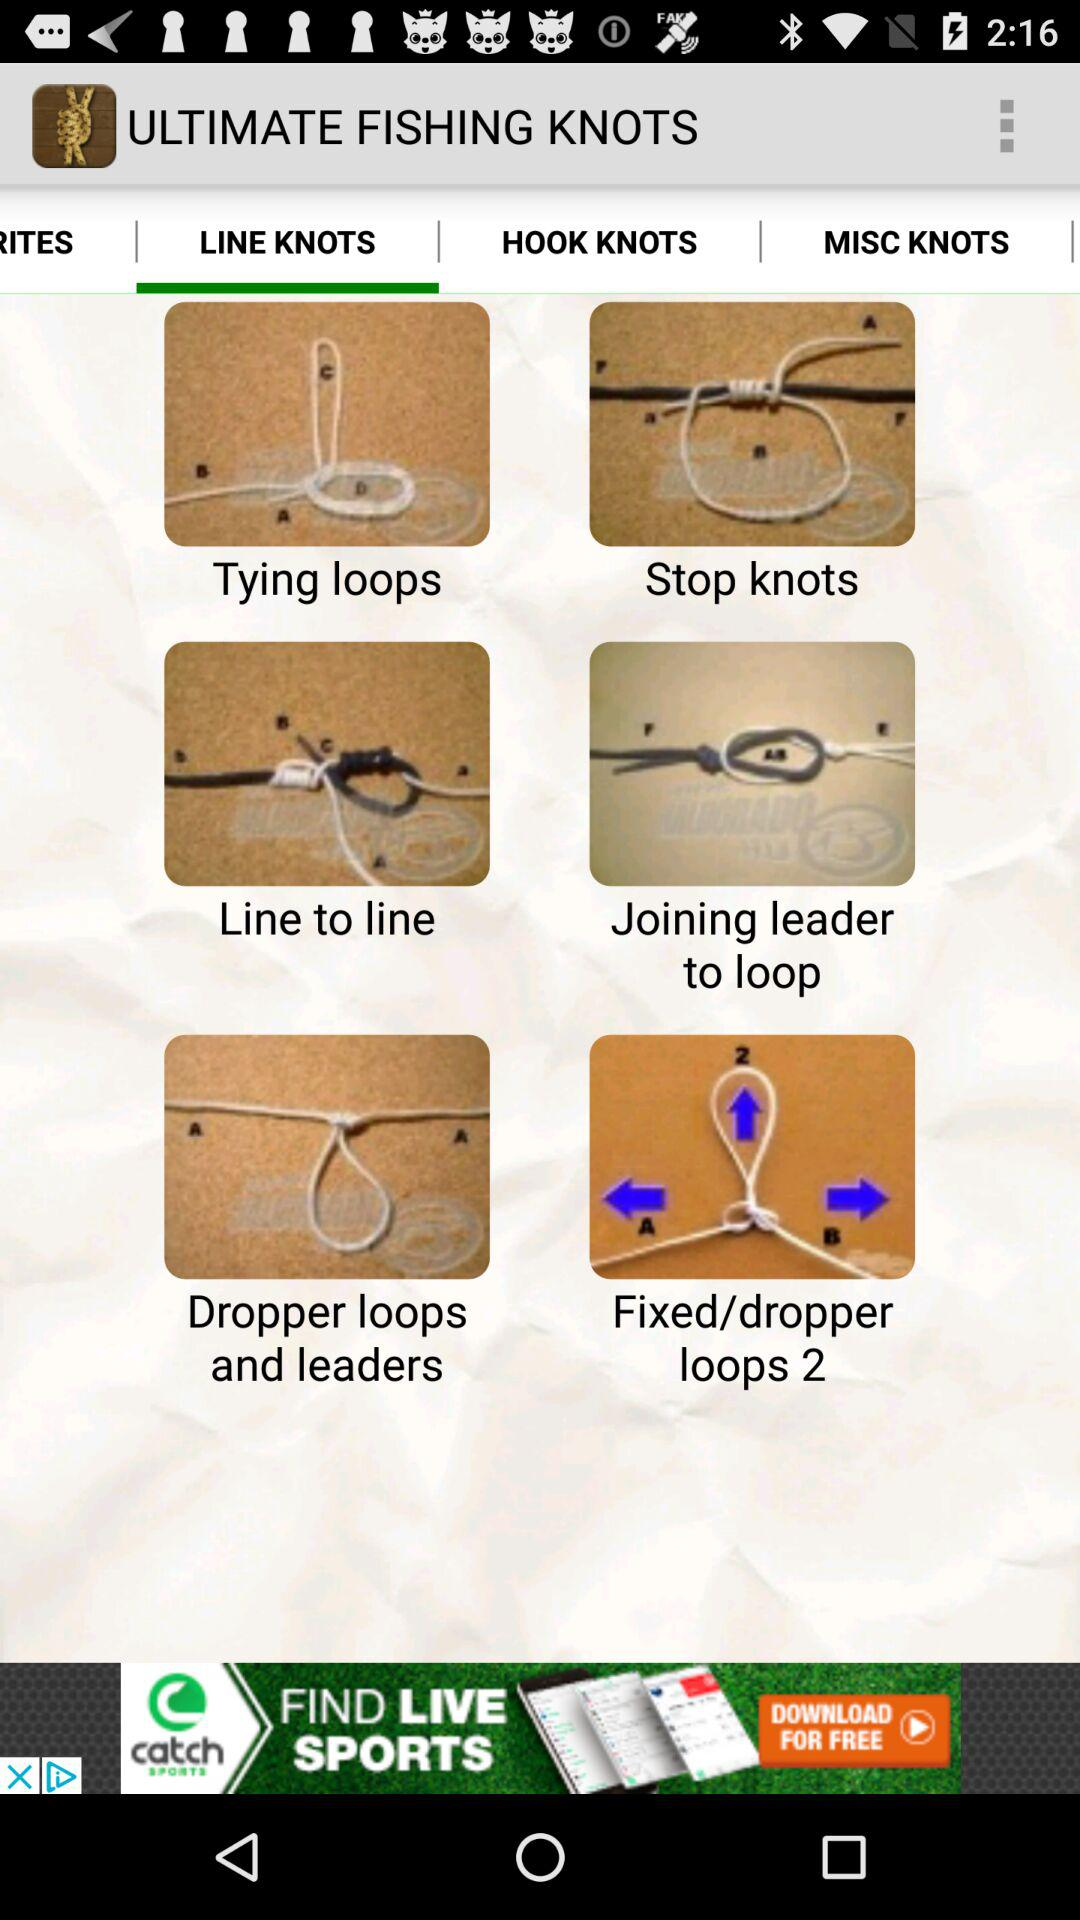What is the name of the application? The name of the application is "ULTIMATE FISHING KNOTS". 